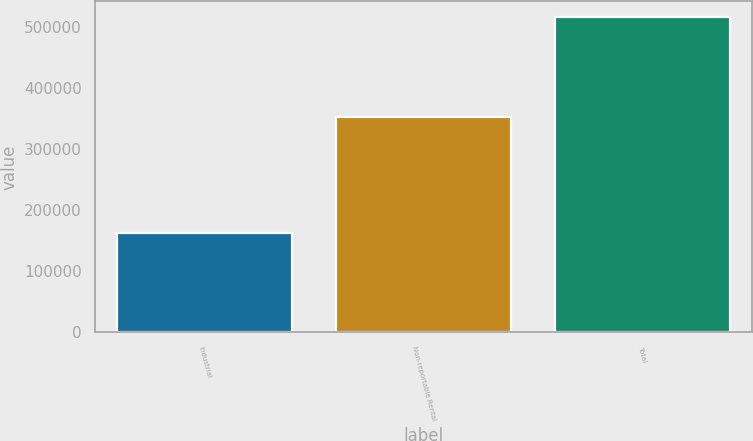Convert chart. <chart><loc_0><loc_0><loc_500><loc_500><bar_chart><fcel>Industrial<fcel>Non-reportable Rental<fcel>Total<nl><fcel>162831<fcel>353734<fcel>516565<nl></chart> 